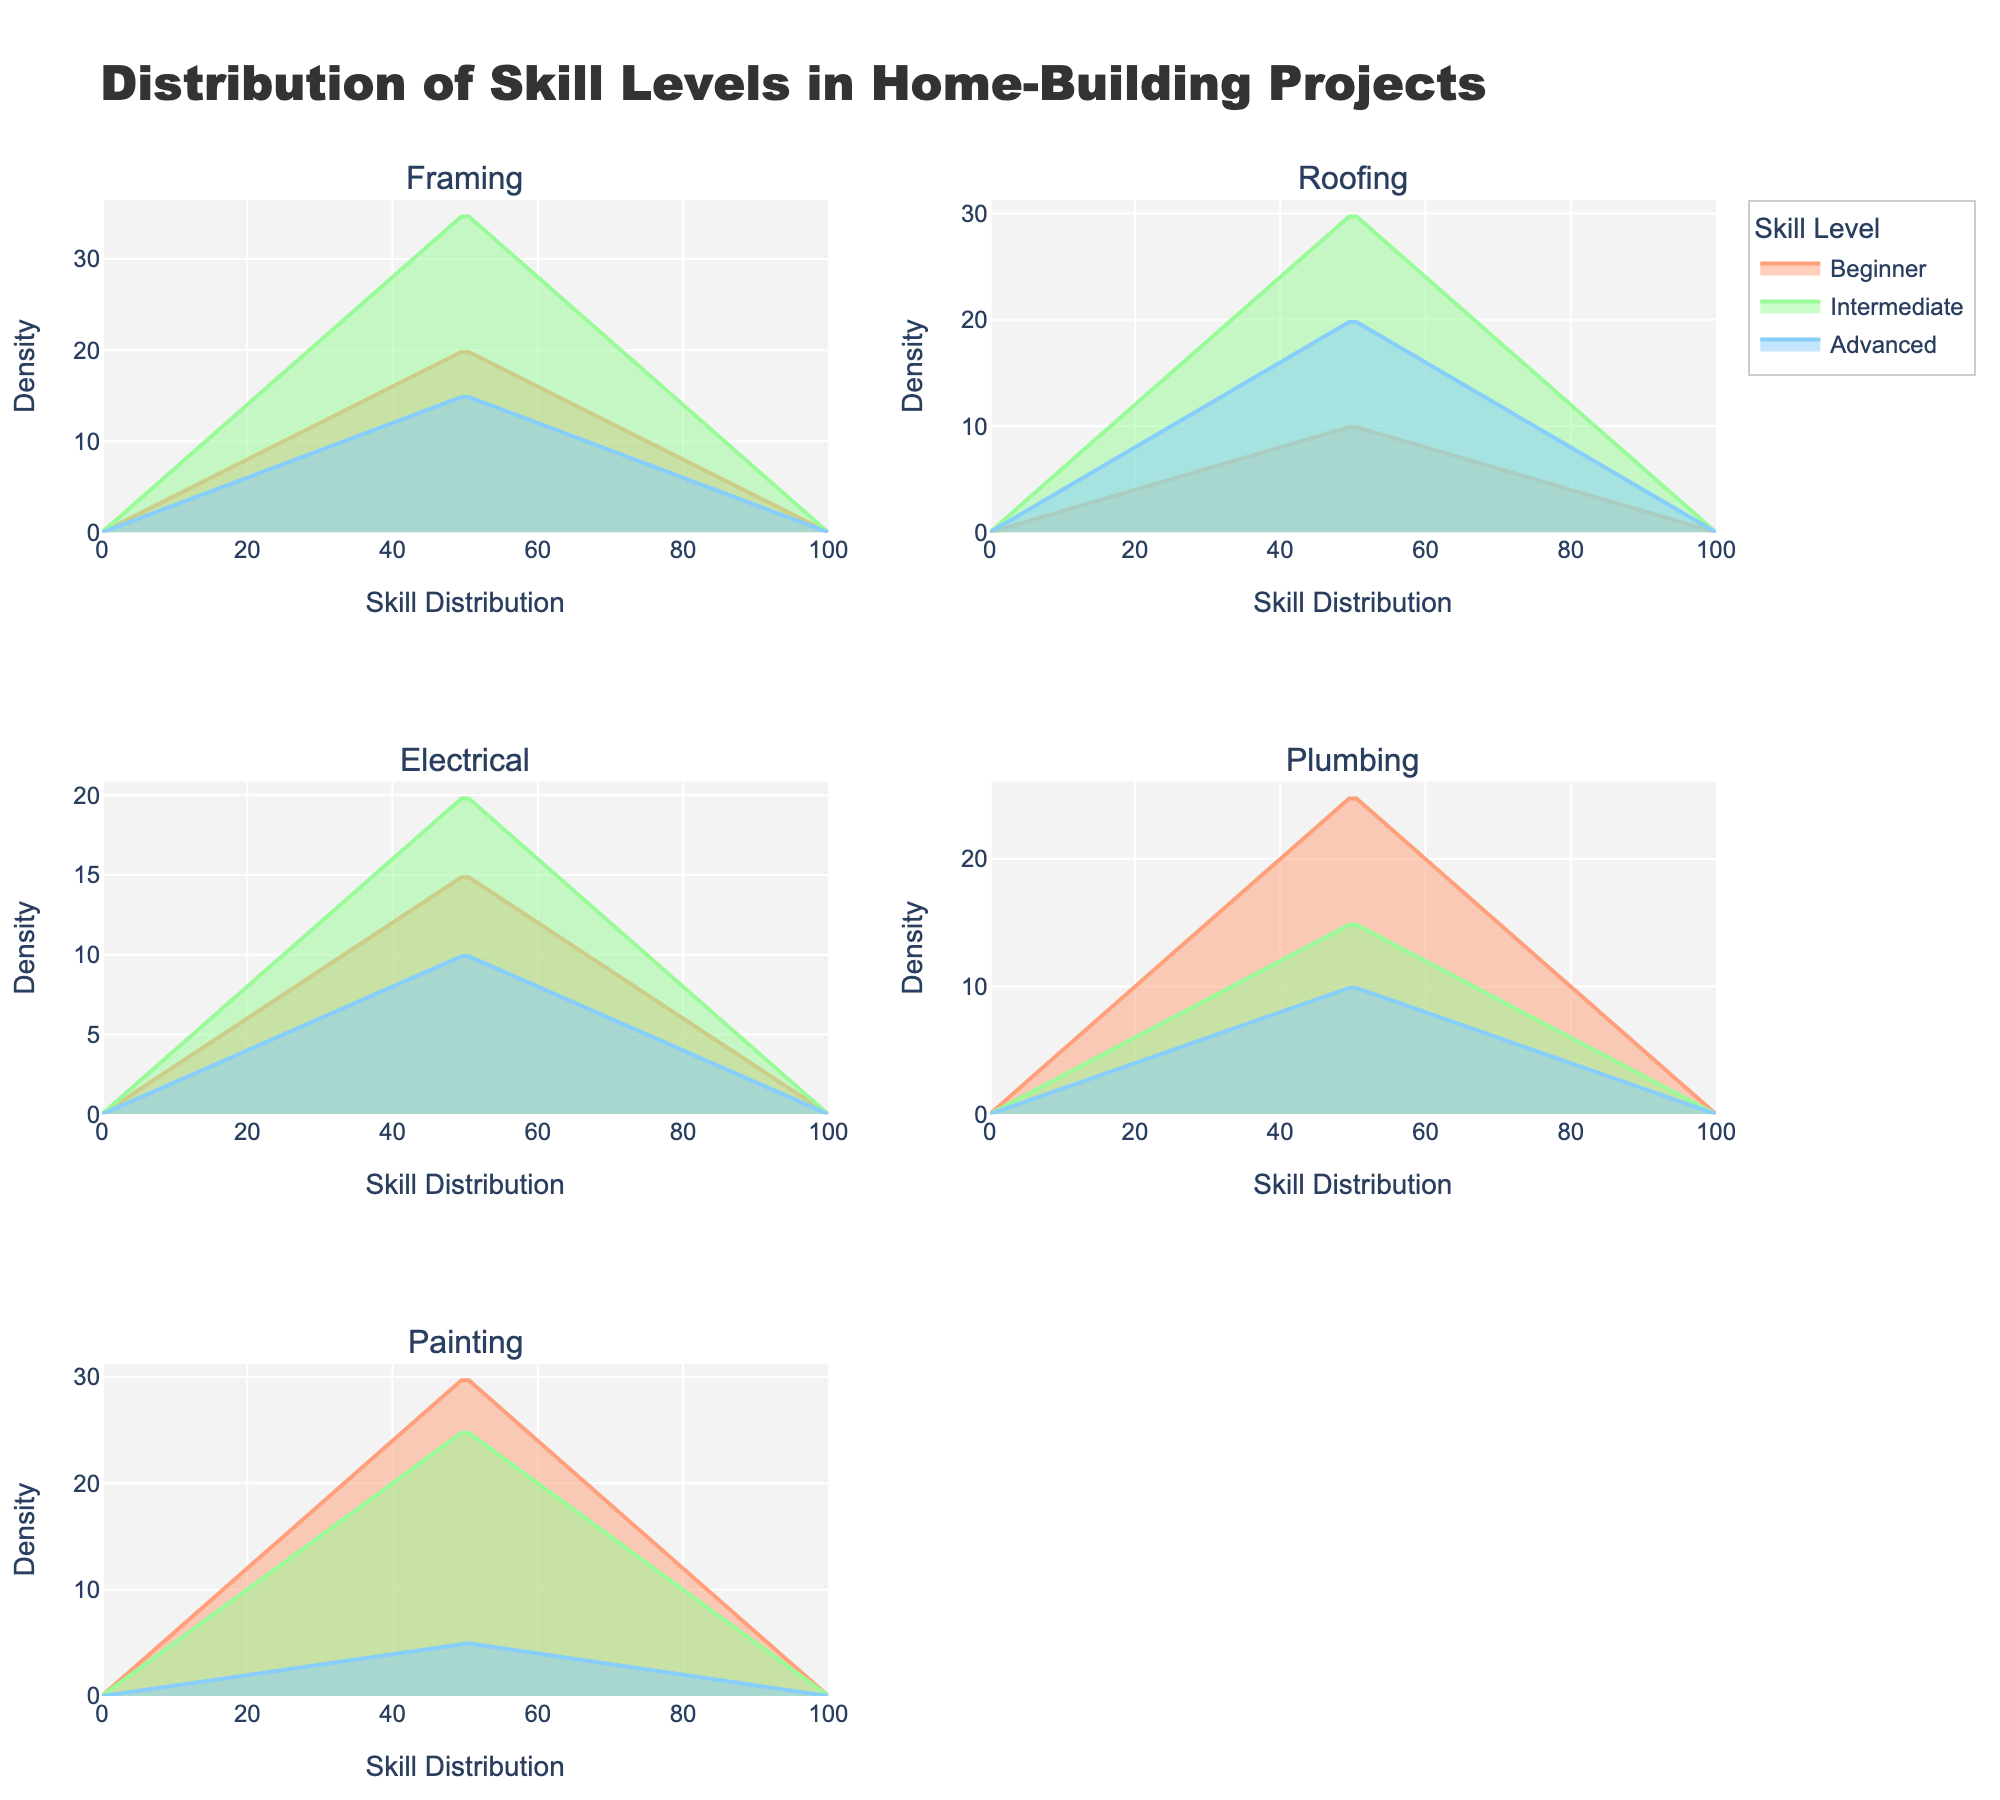What's the title of the plot? The title is located at the top of the figure. It provides an overview of what the plot represents.
Answer: Distribution of Skill Levels in Home-Building Projects What are the skill levels represented in the plot? The skill levels are indicated by the legend. There are three different colors each associated with a skill level.
Answer: Beginner, Intermediate, Advanced Which task has the highest count of beginners? Look at the density plot for each task and identify which one has the highest peak in the "Beginner" skill level color.
Answer: Painting How does the count of advanced volunteers compare between framing and roofing? Compare the heights of the "Advanced" peaks between the two tasks. Framing has a higher count for advanced volunteers compared to roofing.
Answer: Framing has a higher count Which task has the lowest count of intermediate volunteers? Compare the intermediate peaks across all tasks and find the one with the lowest peak. Electrical has the lowest count among the tasks listed in the plot.
Answer: Plumbing What is the average count of beginners across all tasks? Sum the counts of beginners for all tasks and divide by the number of tasks. (20+10+15+25+30) / 5 = 100 / 5 = 20
Answer: 20 Which task shows a more balanced distribution across all skill levels? Look for the task where the peaks of beginner, intermediate, and advanced are relatively close to each other in height. Framing shows a more balanced distribution across all skill levels.
Answer: Framing Is the density plot wider for beginners or advanced volunteers on the painting task? Compare the width of the density plots for the "Beginner" and "Advanced" skill levels in the painting task. The beginner plot is much wider in comparison.
Answer: Beginners Which skill level is most common across all tasks? Check which skill level consistently has the highest density peak across multiple tasks. Intermediate is generally the most common skill level.
Answer: Intermediate Among electrical and plumbing tasks, which has a higher count of intermediate volunteers? Compare the heights of the intermediate peaks for both electrical and plumbing tasks. Electrical has a higher peak compared to plumbing.
Answer: Electrical 